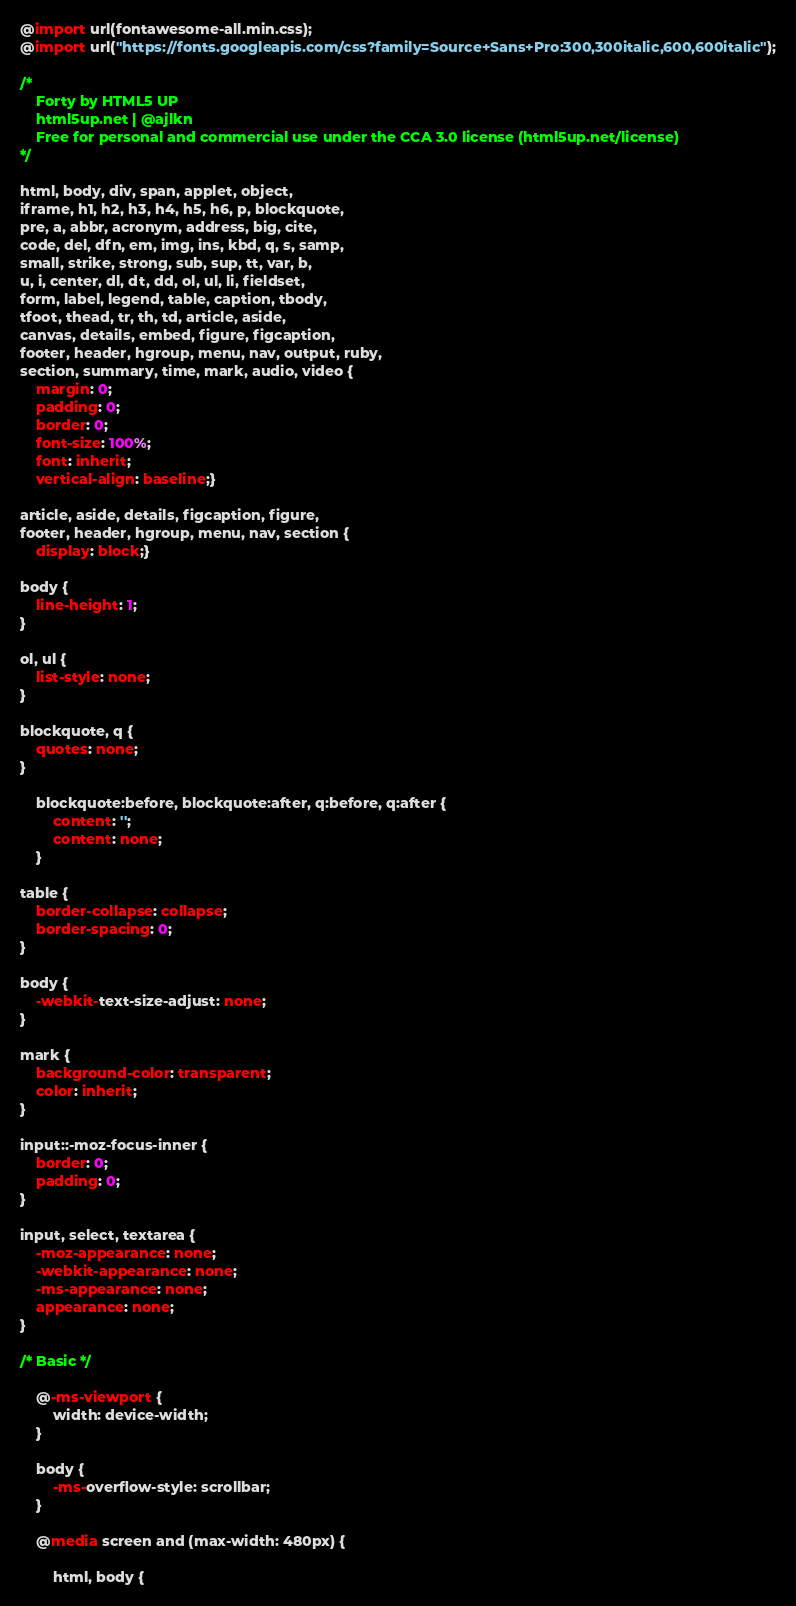Convert code to text. <code><loc_0><loc_0><loc_500><loc_500><_CSS_>@import url(fontawesome-all.min.css);
@import url("https://fonts.googleapis.com/css?family=Source+Sans+Pro:300,300italic,600,600italic");

/*
	Forty by HTML5 UP
	html5up.net | @ajlkn
	Free for personal and commercial use under the CCA 3.0 license (html5up.net/license)
*/

html, body, div, span, applet, object,
iframe, h1, h2, h3, h4, h5, h6, p, blockquote,
pre, a, abbr, acronym, address, big, cite,
code, del, dfn, em, img, ins, kbd, q, s, samp,
small, strike, strong, sub, sup, tt, var, b,
u, i, center, dl, dt, dd, ol, ul, li, fieldset,
form, label, legend, table, caption, tbody,
tfoot, thead, tr, th, td, article, aside,
canvas, details, embed, figure, figcaption,
footer, header, hgroup, menu, nav, output, ruby,
section, summary, time, mark, audio, video {
	margin: 0;
	padding: 0;
	border: 0;
	font-size: 100%;
	font: inherit;
	vertical-align: baseline;}

article, aside, details, figcaption, figure,
footer, header, hgroup, menu, nav, section {
	display: block;}

body {
	line-height: 1;
}

ol, ul {
	list-style: none;
}

blockquote, q {
	quotes: none;
}

	blockquote:before, blockquote:after, q:before, q:after {
		content: '';
		content: none;
	}

table {
	border-collapse: collapse;
	border-spacing: 0;
}

body {
	-webkit-text-size-adjust: none;
}

mark {
	background-color: transparent;
	color: inherit;
}

input::-moz-focus-inner {
	border: 0;
	padding: 0;
}

input, select, textarea {
	-moz-appearance: none;
	-webkit-appearance: none;
	-ms-appearance: none;
	appearance: none;
}

/* Basic */

	@-ms-viewport {
		width: device-width;
	}

	body {
		-ms-overflow-style: scrollbar;
	}

	@media screen and (max-width: 480px) {

		html, body {</code> 